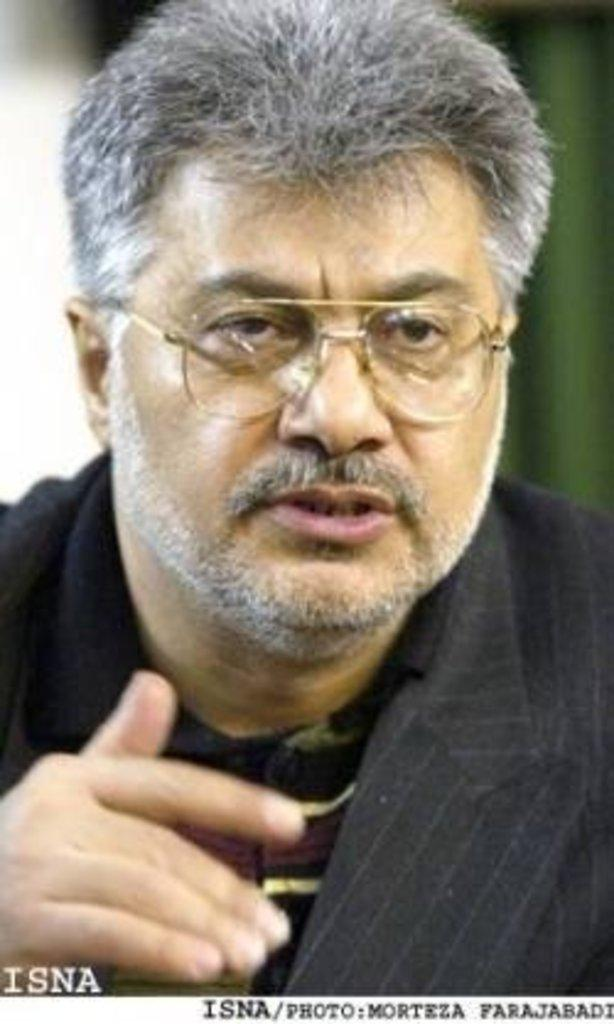Who is in the image? There is a man in the image. Can you describe any additional features of the image? The watermark is present at the bottom of the image. What type of desk is visible in the image? There is no desk present in the image. Can you describe the contents of the jar in the image? There is no jar present in the image. 